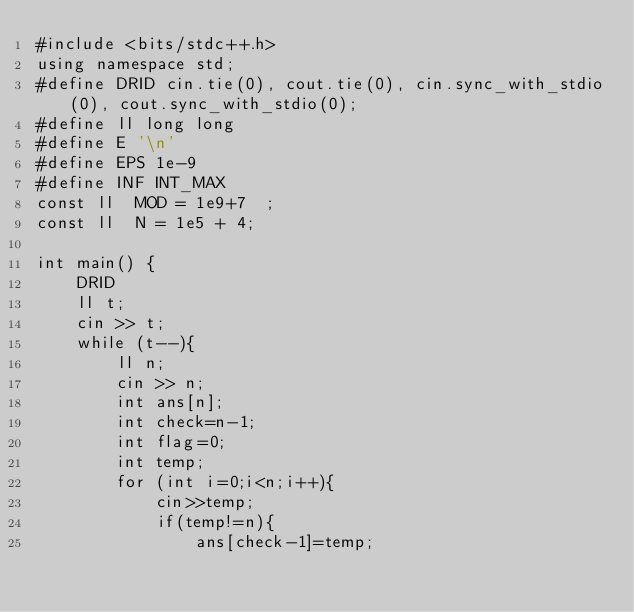<code> <loc_0><loc_0><loc_500><loc_500><_C++_>#include <bits/stdc++.h>
using namespace std;
#define DRID cin.tie(0), cout.tie(0), cin.sync_with_stdio(0), cout.sync_with_stdio(0);
#define ll long long
#define E '\n'
#define EPS 1e-9
#define INF INT_MAX
const ll  MOD = 1e9+7  ;
const ll  N = 1e5 + 4;
 
int main() {
    DRID
    ll t;
    cin >> t;
    while (t--){
        ll n;
        cin >> n;
        int ans[n];
        int check=n-1;
        int flag=0;
        int temp;
        for (int i=0;i<n;i++){
            cin>>temp;
            if(temp!=n){
                ans[check-1]=temp;</code> 